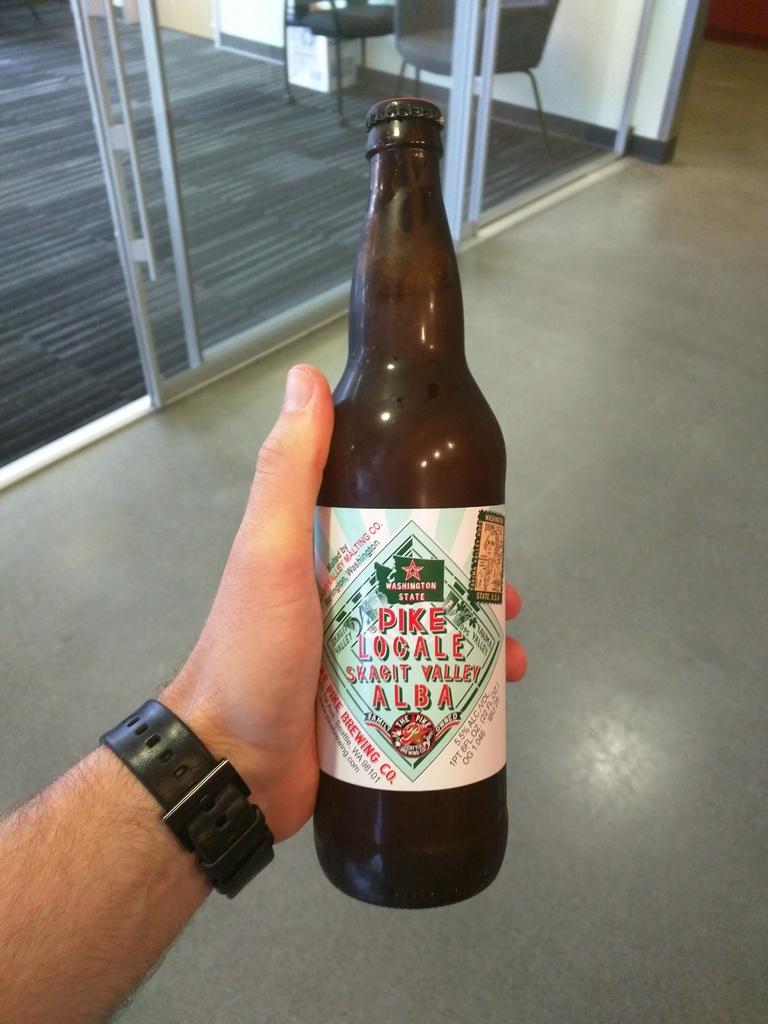What state was this likely made in?
Offer a very short reply. Washington. 